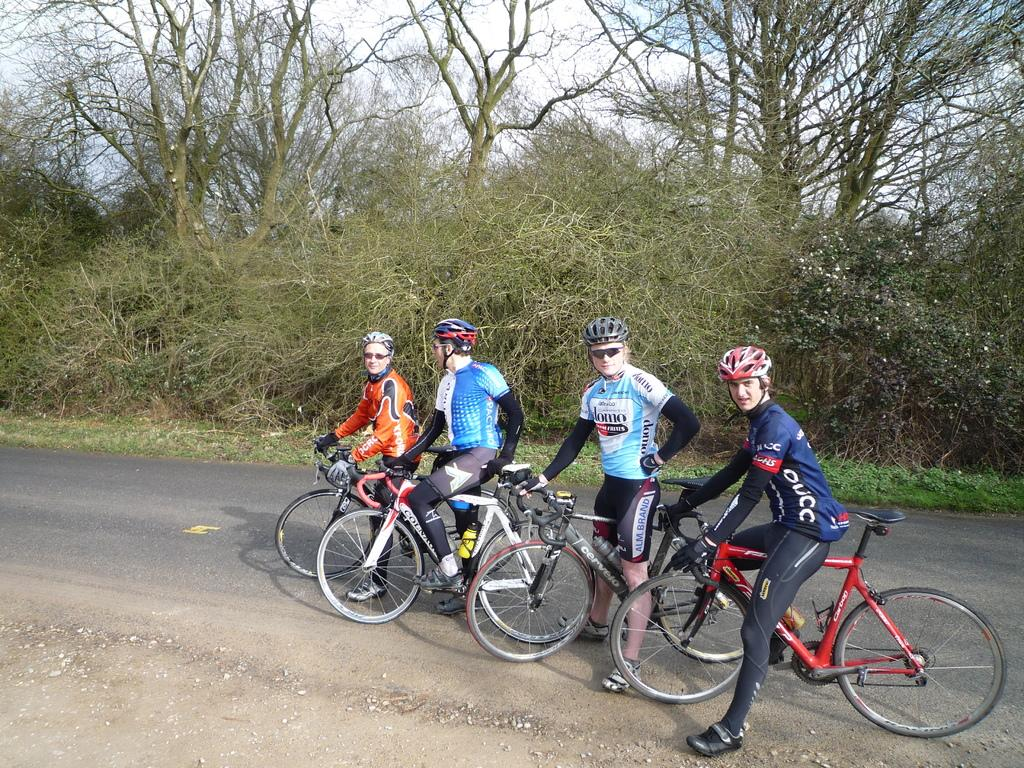What are the people in the image doing? The people in the image are on bicycles. What is the setting of the image? There is a road in the image. What can be seen on the path in the image? Plants are visible on the path in the image. What is visible in the background of the image? Trees are visible in the background of the image. What type of food is being prepared on the bicycle in the image? There is no food preparation or cooking activity visible in the image; the people are simply riding bicycles. 